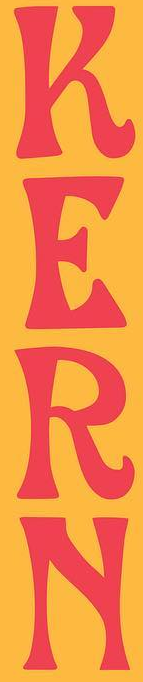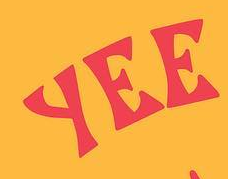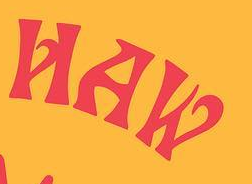What words can you see in these images in sequence, separated by a semicolon? KERN; YEE; HAW 